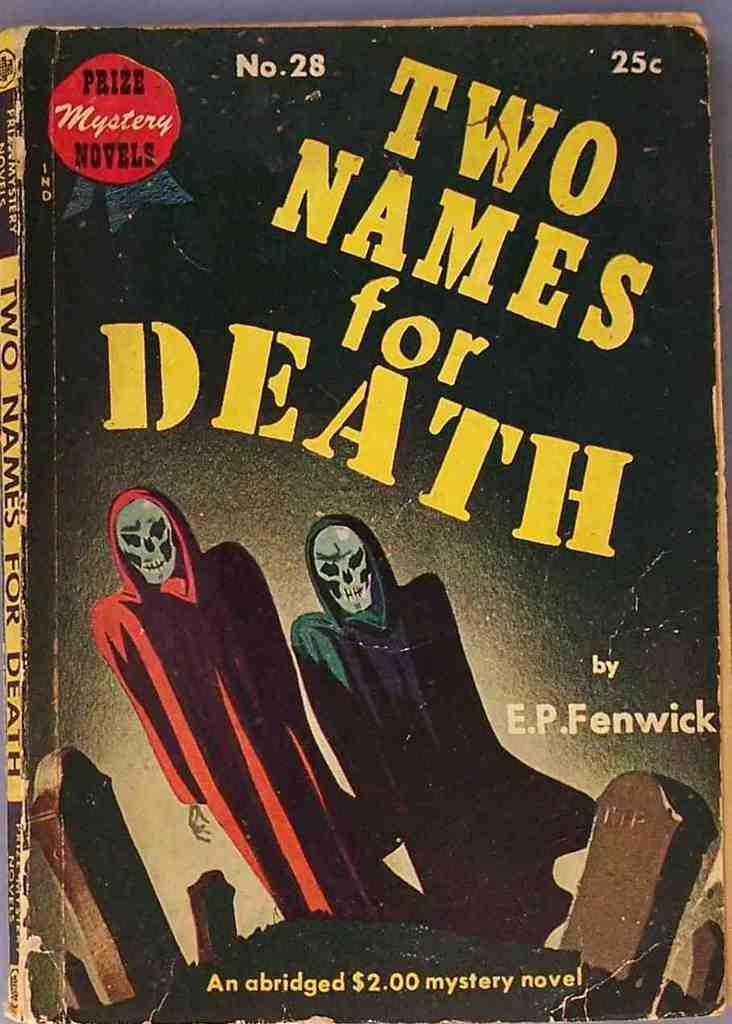Provide a one-sentence caption for the provided image. A book numbered twenty eight has a twenty five cent price tag in the corner. 